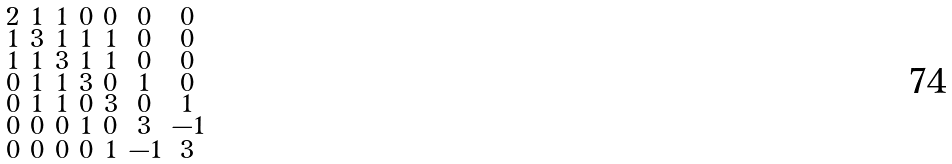<formula> <loc_0><loc_0><loc_500><loc_500>\begin{smallmatrix} 2 & 1 & 1 & 0 & 0 & 0 & 0 \\ 1 & 3 & 1 & 1 & 1 & 0 & 0 \\ 1 & 1 & 3 & 1 & 1 & 0 & 0 \\ 0 & 1 & 1 & 3 & 0 & 1 & 0 \\ 0 & 1 & 1 & 0 & 3 & 0 & 1 \\ 0 & 0 & 0 & 1 & 0 & 3 & - 1 \\ 0 & 0 & 0 & 0 & 1 & - 1 & 3 \end{smallmatrix}</formula> 